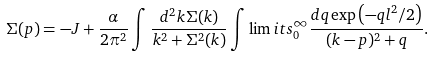<formula> <loc_0><loc_0><loc_500><loc_500>\Sigma ( p ) = - J + \frac { \alpha } { 2 \pi ^ { 2 } } \int \frac { d ^ { 2 } k \Sigma ( k ) } { k ^ { 2 } + \Sigma ^ { 2 } ( k ) } \int \lim i t s _ { 0 } ^ { \infty } \frac { d q \exp \left ( - q l ^ { 2 } / 2 \right ) } { ( k - p ) ^ { 2 } + q } .</formula> 